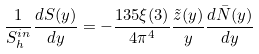<formula> <loc_0><loc_0><loc_500><loc_500>\frac { 1 } { S _ { h } ^ { i n } } \frac { d S ( y ) } { d y } = - \frac { 1 3 5 \xi ( 3 ) } { 4 \pi ^ { 4 } } \frac { \tilde { z } ( y ) } { y } \frac { d \bar { N } ( y ) } { d y }</formula> 